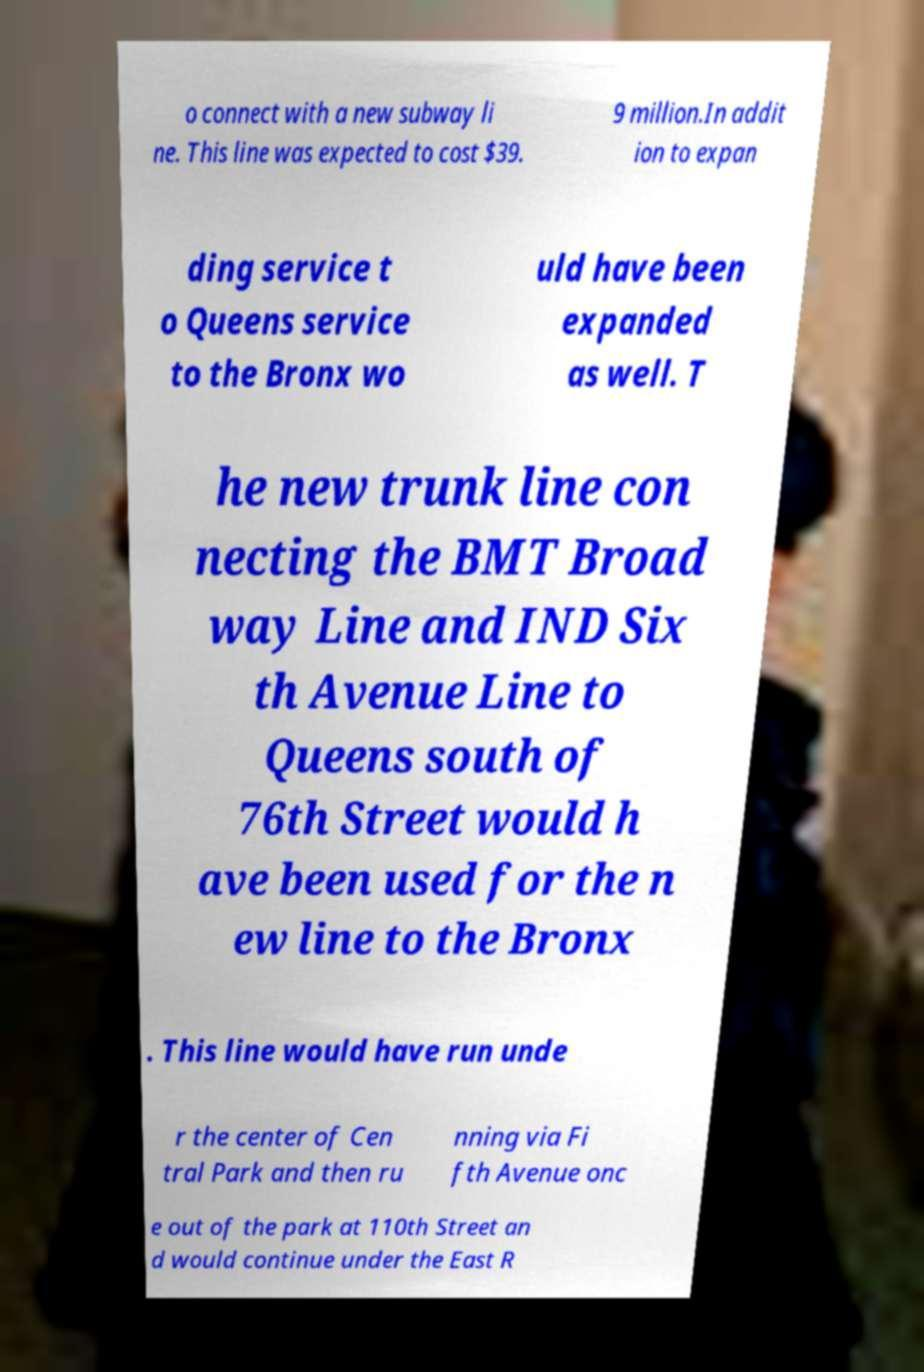What messages or text are displayed in this image? I need them in a readable, typed format. o connect with a new subway li ne. This line was expected to cost $39. 9 million.In addit ion to expan ding service t o Queens service to the Bronx wo uld have been expanded as well. T he new trunk line con necting the BMT Broad way Line and IND Six th Avenue Line to Queens south of 76th Street would h ave been used for the n ew line to the Bronx . This line would have run unde r the center of Cen tral Park and then ru nning via Fi fth Avenue onc e out of the park at 110th Street an d would continue under the East R 